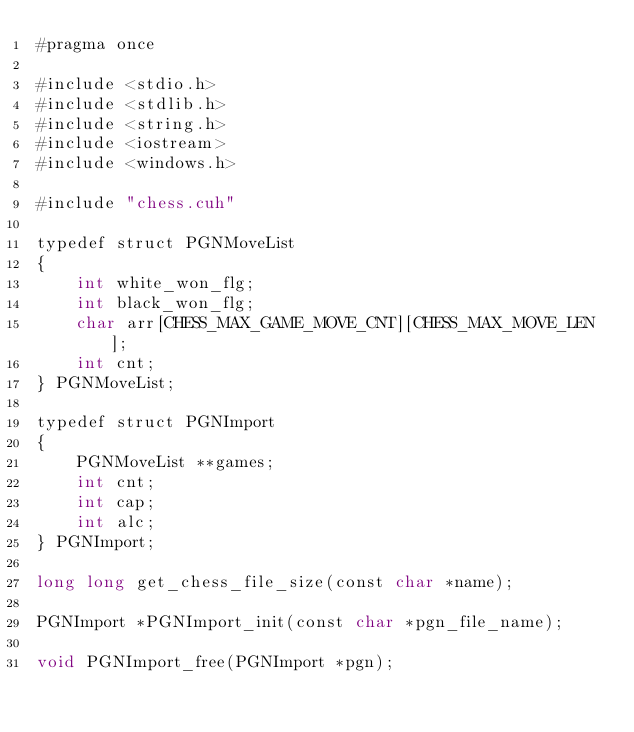Convert code to text. <code><loc_0><loc_0><loc_500><loc_500><_Cuda_>#pragma once

#include <stdio.h>
#include <stdlib.h>
#include <string.h>
#include <iostream>
#include <windows.h>

#include "chess.cuh"

typedef struct PGNMoveList
{
    int white_won_flg;
    int black_won_flg;
    char arr[CHESS_MAX_GAME_MOVE_CNT][CHESS_MAX_MOVE_LEN];
    int cnt;
} PGNMoveList;

typedef struct PGNImport
{
    PGNMoveList **games;
    int cnt;
    int cap;
    int alc;
} PGNImport;

long long get_chess_file_size(const char *name);

PGNImport *PGNImport_init(const char *pgn_file_name);

void PGNImport_free(PGNImport *pgn);</code> 